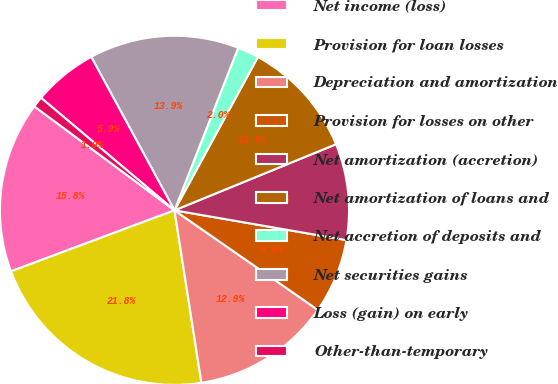Convert chart. <chart><loc_0><loc_0><loc_500><loc_500><pie_chart><fcel>Net income (loss)<fcel>Provision for loan losses<fcel>Depreciation and amortization<fcel>Provision for losses on other<fcel>Net amortization (accretion)<fcel>Net amortization of loans and<fcel>Net accretion of deposits and<fcel>Net securities gains<fcel>Loss (gain) on early<fcel>Other-than-temporary<nl><fcel>15.84%<fcel>21.78%<fcel>12.87%<fcel>6.93%<fcel>8.91%<fcel>10.89%<fcel>1.98%<fcel>13.86%<fcel>5.94%<fcel>0.99%<nl></chart> 